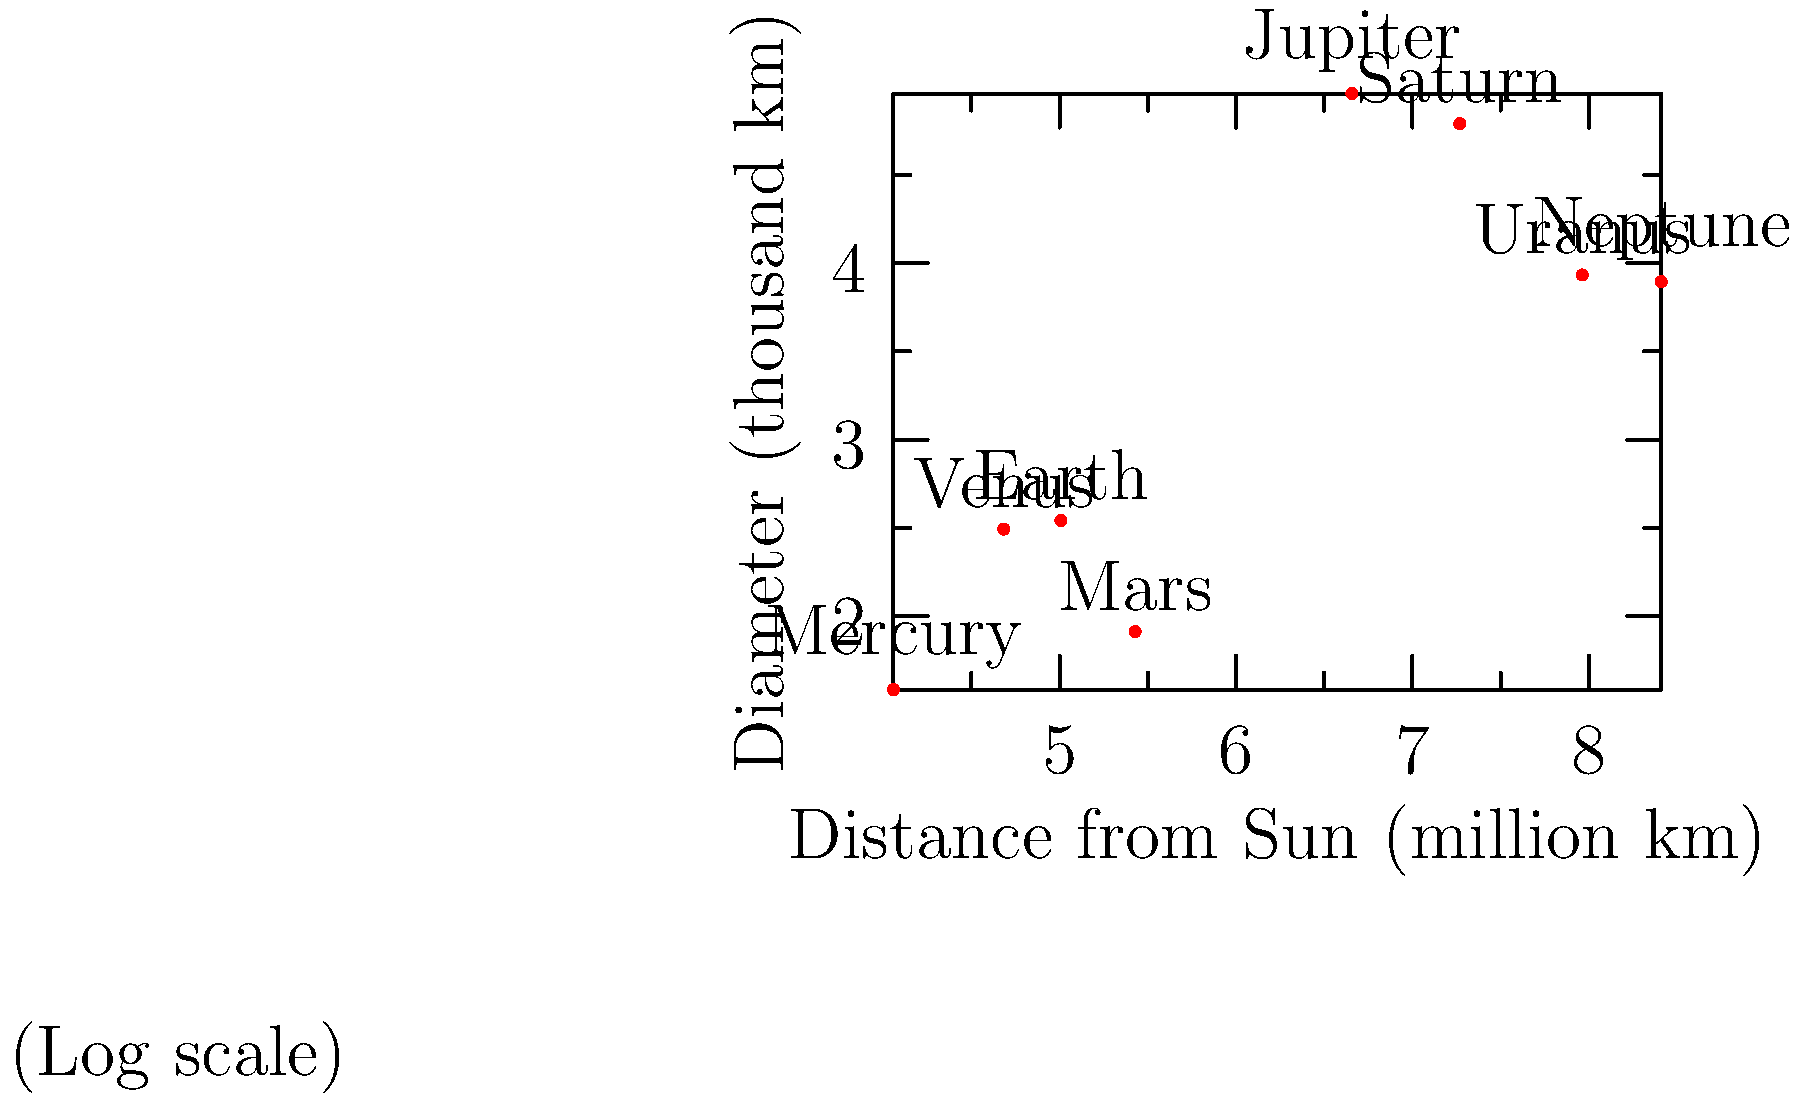In the context of planetary science, analyze the relationship between a planet's size and its distance from the Sun as depicted in the logarithmic plot. How does this graphical representation challenge or support the concept of the "frost line" in planetary formation theory? To answer this question, let's analyze the graph step-by-step:

1. The graph shows the relationship between planet size (diameter) and distance from the Sun, both on logarithmic scales.

2. The "frost line" in planetary formation theory is typically located between Mars and Jupiter, around 2.7-3.1 AU from the Sun.

3. Observing the graph:
   a) The inner planets (Mercury, Venus, Earth, Mars) are smaller and closer to the Sun.
   b) There's a significant jump in both size and distance between Mars and Jupiter.
   c) The outer planets (Jupiter, Saturn, Uranus, Neptune) are larger and farther from the Sun.

4. The frost line concept suggests:
   a) Rocky, terrestrial planets form inside the frost line.
   b) Gas giants form beyond the frost line, where volatile compounds can condense into solid ice grains.

5. The graph supports this theory:
   a) The sudden increase in planet size coincides with the approximate location of the frost line.
   b) This transition occurs between Mars and Jupiter, consistent with the theoretical frost line location.

6. However, the graph also shows some nuances:
   a) There's a slight size decrease from Jupiter to Saturn, then to Uranus and Neptune.
   b) This suggests that while the frost line is important, other factors also influence planet size.

7. The logarithmic scale is crucial here:
   a) It allows us to visualize vast differences in both size and distance on a single plot.
   b) It emphasizes the proportional relationships rather than absolute differences.

In conclusion, the graph largely supports the frost line concept by showing a clear division between smaller, closer planets and larger, distant ones. However, it also hints at the complexity of planetary formation, suggesting that while the frost line is a key factor, it's not the only determinant of planetary characteristics.
Answer: The graph supports the frost line theory, showing a clear size increase beyond Mars, but also reveals complexities in planetary formation. 